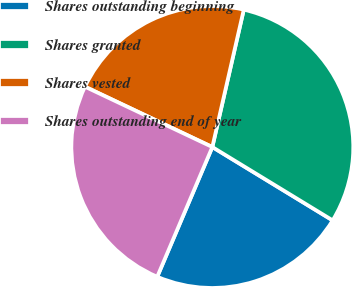<chart> <loc_0><loc_0><loc_500><loc_500><pie_chart><fcel>Shares outstanding beginning<fcel>Shares granted<fcel>Shares vested<fcel>Shares outstanding end of year<nl><fcel>22.68%<fcel>30.13%<fcel>21.54%<fcel>25.65%<nl></chart> 